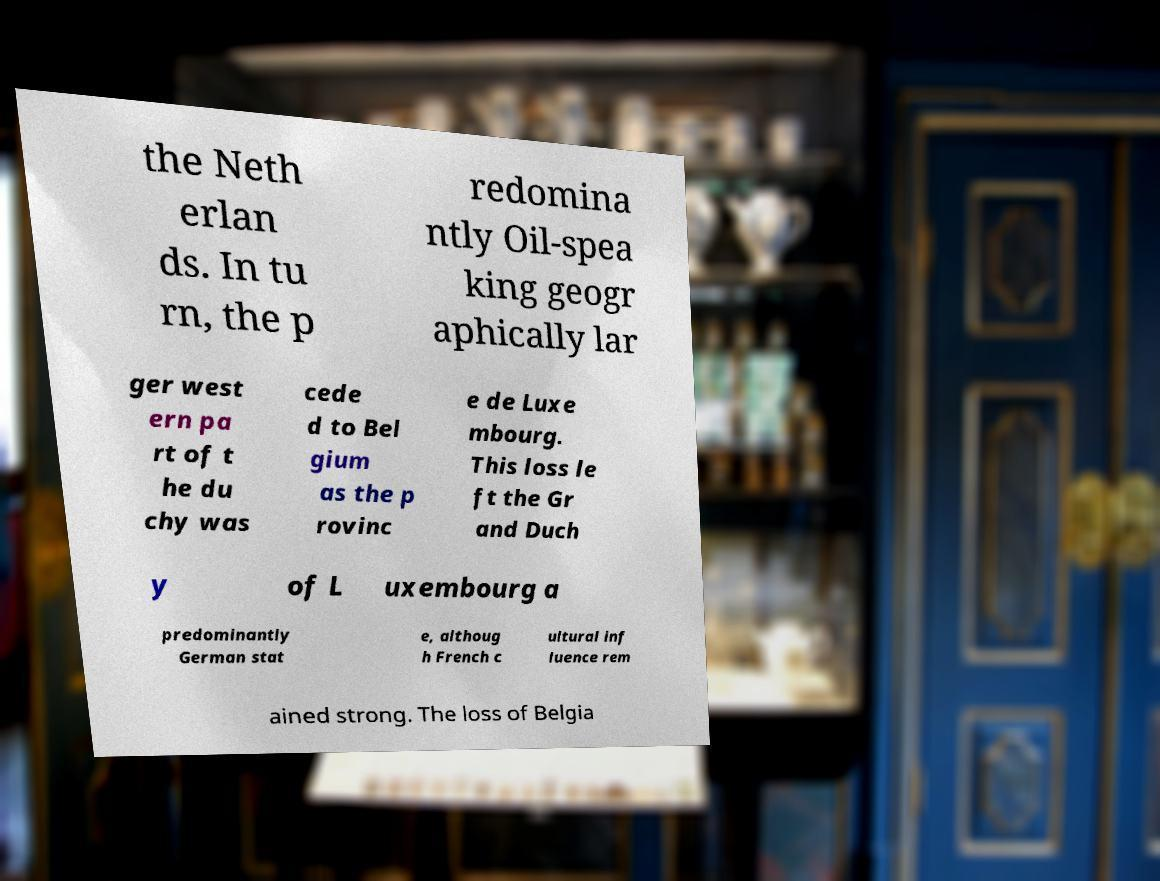I need the written content from this picture converted into text. Can you do that? the Neth erlan ds. In tu rn, the p redomina ntly Oil-spea king geogr aphically lar ger west ern pa rt of t he du chy was cede d to Bel gium as the p rovinc e de Luxe mbourg. This loss le ft the Gr and Duch y of L uxembourg a predominantly German stat e, althoug h French c ultural inf luence rem ained strong. The loss of Belgia 